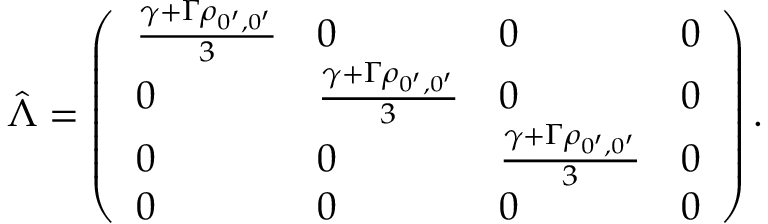<formula> <loc_0><loc_0><loc_500><loc_500>\hat { \Lambda } = \left ( \begin{array} { l l l l } { \frac { \gamma + \Gamma \rho _ { 0 ^ { \prime } , 0 ^ { \prime } } } { 3 } } & { 0 } & { 0 } & { 0 } \\ { 0 } & { \frac { \gamma + \Gamma \rho _ { 0 ^ { \prime } , 0 ^ { \prime } } } { 3 } } & { 0 } & { 0 } \\ { 0 } & { 0 } & { \frac { \gamma + \Gamma \rho _ { 0 ^ { \prime } , 0 ^ { \prime } } } { 3 } } & { 0 } \\ { 0 } & { 0 } & { 0 } & { 0 } \end{array} \right ) .</formula> 